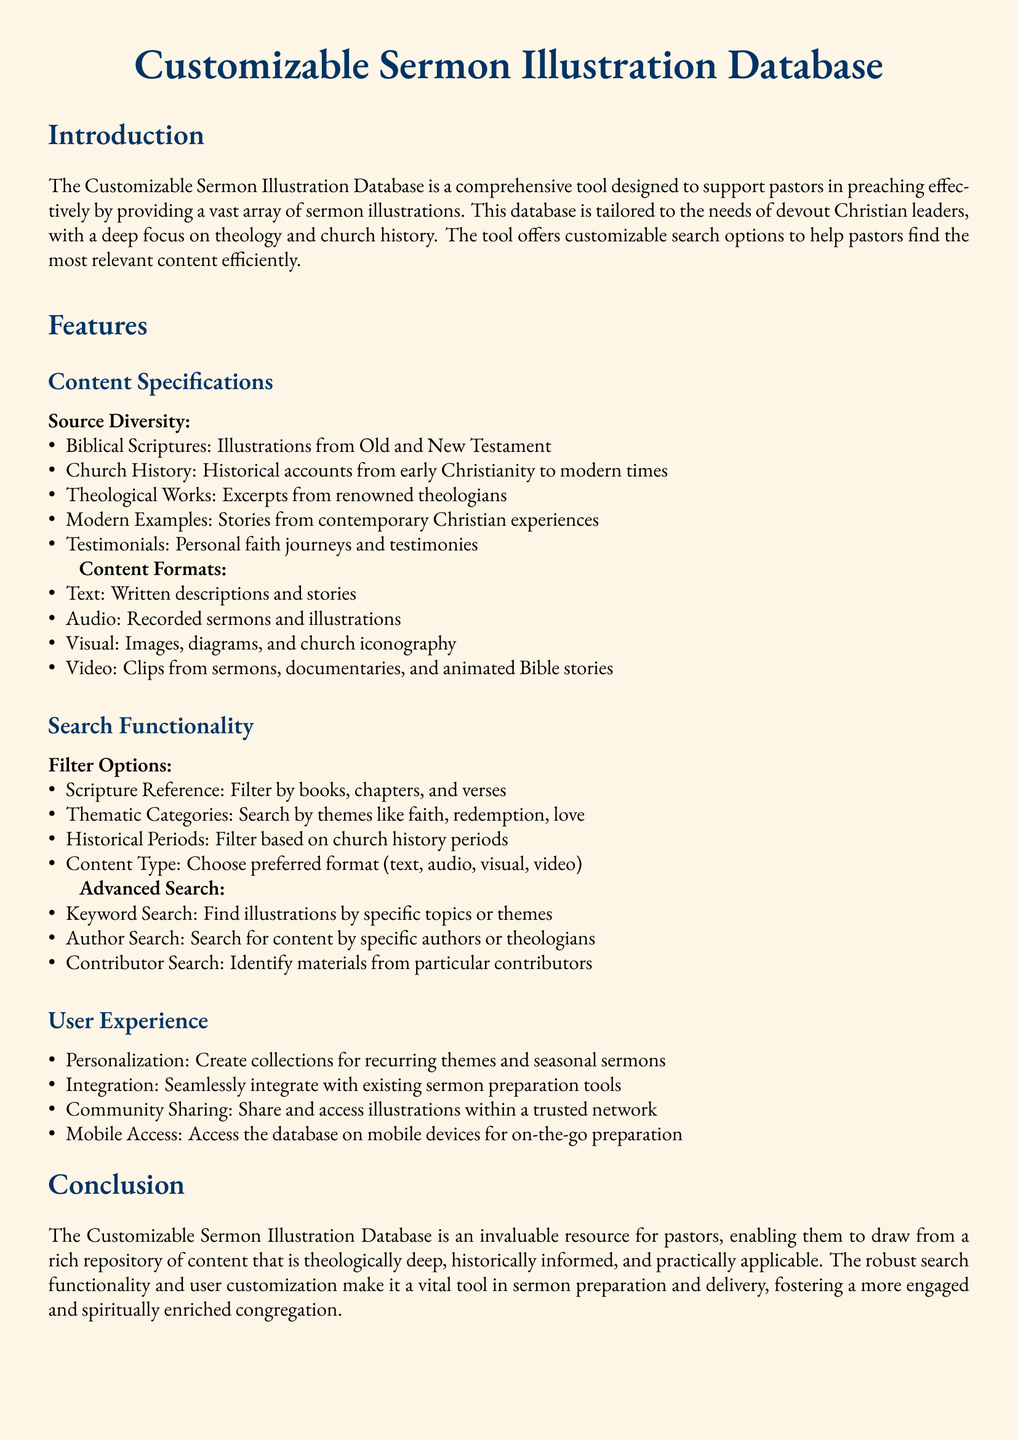What is the primary purpose of the Customizable Sermon Illustration Database? The primary purpose is to support pastors in preaching effectively by providing a vast array of sermon illustrations.
Answer: support pastors in preaching effectively How many content formats are mentioned in the database? The document lists four content formats: Text, Audio, Visual, and Video.
Answer: four What types of search filter options are available? The search filter options include Scripture Reference, Thematic Categories, Historical Periods, and Content Type.
Answer: Scripture Reference, Thematic Categories, Historical Periods, Content Type Which features allow user personalization? User personalization is facilitated through the ability to create collections for recurring themes and seasonal sermons.
Answer: create collections for recurring themes and seasonal sermons What types of content does the Source Diversity section include? The Source Diversity section includes Biblical Scriptures, Church History, Theological Works, Modern Examples, and Testimonials.
Answer: Biblical Scriptures, Church History, Theological Works, Modern Examples, Testimonials What functionality does the Advanced Search provide? The Advanced Search allows Keyword Search, Author Search, and Contributor Search.
Answer: Keyword Search, Author Search, Contributor Search 